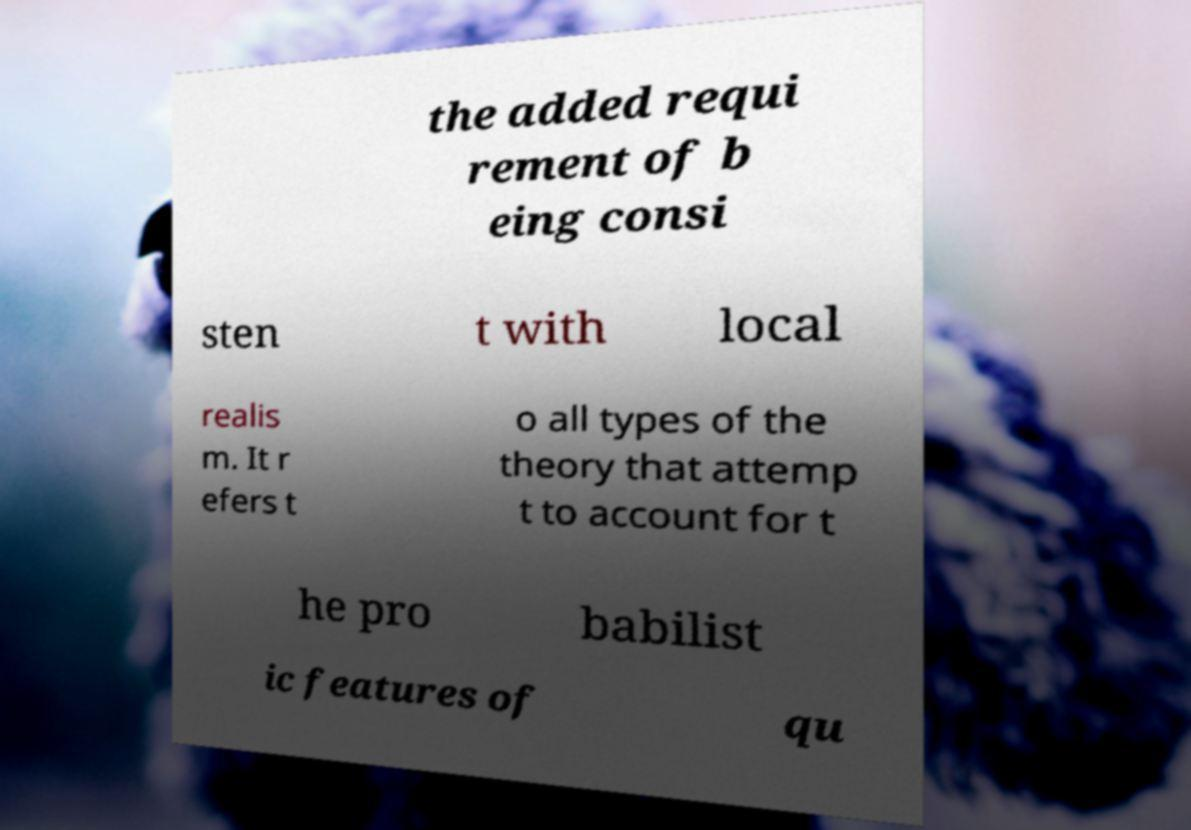I need the written content from this picture converted into text. Can you do that? the added requi rement of b eing consi sten t with local realis m. It r efers t o all types of the theory that attemp t to account for t he pro babilist ic features of qu 